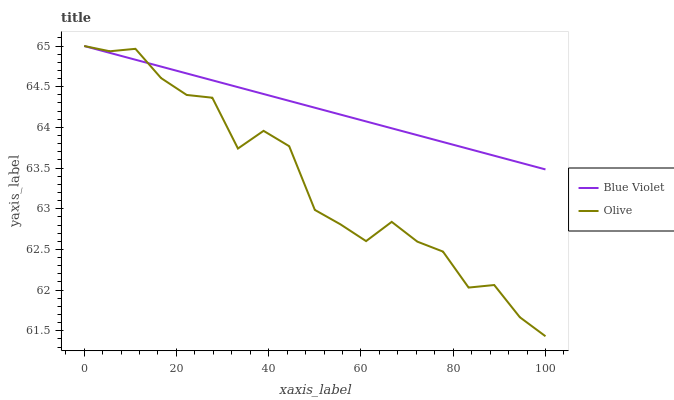Does Olive have the minimum area under the curve?
Answer yes or no. Yes. Does Blue Violet have the maximum area under the curve?
Answer yes or no. Yes. Does Blue Violet have the minimum area under the curve?
Answer yes or no. No. Is Blue Violet the smoothest?
Answer yes or no. Yes. Is Olive the roughest?
Answer yes or no. Yes. Is Blue Violet the roughest?
Answer yes or no. No. Does Olive have the lowest value?
Answer yes or no. Yes. Does Blue Violet have the lowest value?
Answer yes or no. No. Does Blue Violet have the highest value?
Answer yes or no. Yes. Does Olive intersect Blue Violet?
Answer yes or no. Yes. Is Olive less than Blue Violet?
Answer yes or no. No. Is Olive greater than Blue Violet?
Answer yes or no. No. 